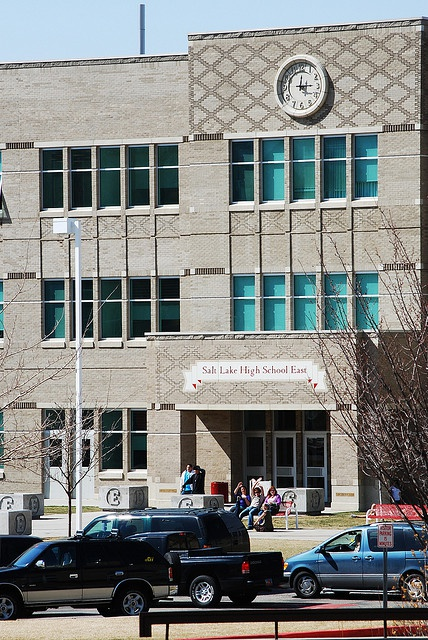Describe the objects in this image and their specific colors. I can see truck in lightblue, black, gray, navy, and blue tones, car in lightblue, black, navy, blue, and gray tones, truck in lightblue, black, gray, navy, and blue tones, car in lightblue, black, navy, blue, and teal tones, and clock in lightblue, lightgray, gray, darkgray, and black tones in this image. 